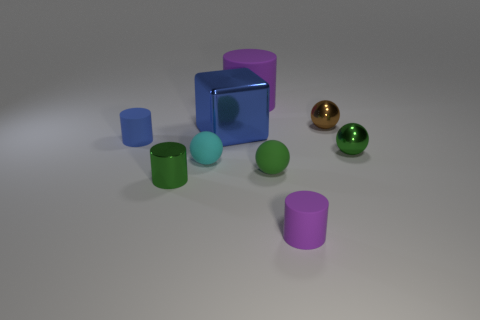Are there any cyan objects to the left of the tiny cyan object? no 